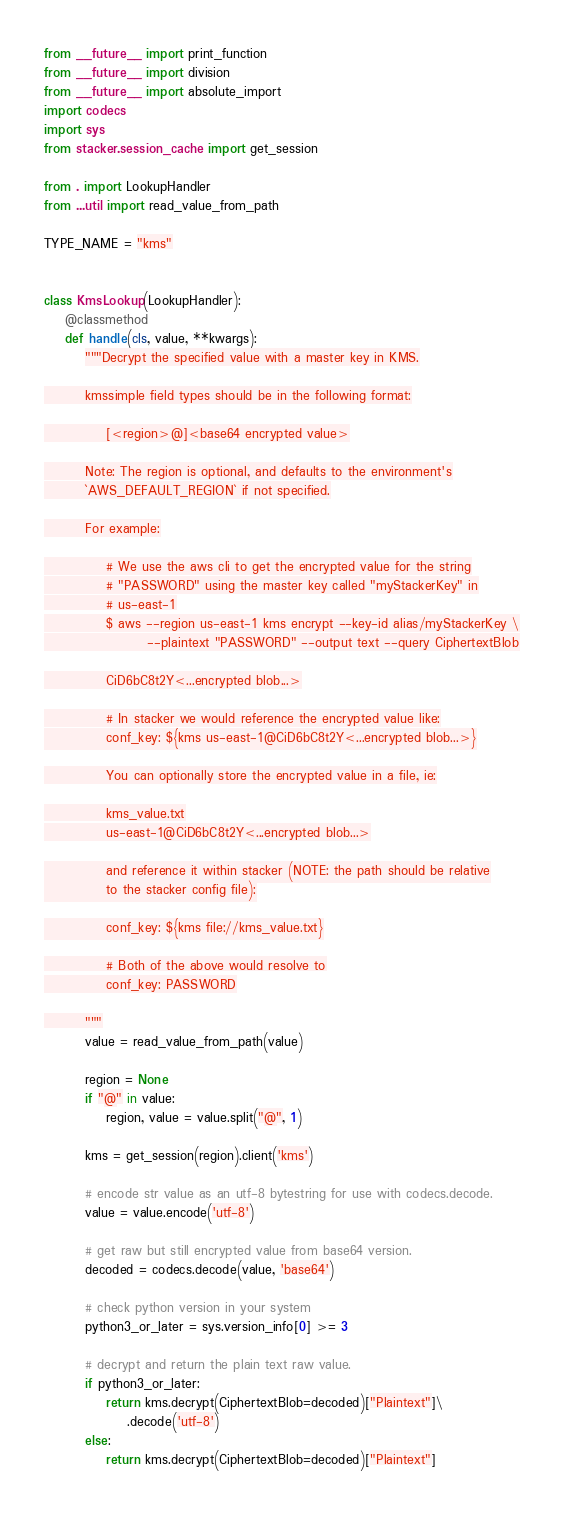<code> <loc_0><loc_0><loc_500><loc_500><_Python_>from __future__ import print_function
from __future__ import division
from __future__ import absolute_import
import codecs
import sys
from stacker.session_cache import get_session

from . import LookupHandler
from ...util import read_value_from_path

TYPE_NAME = "kms"


class KmsLookup(LookupHandler):
    @classmethod
    def handle(cls, value, **kwargs):
        """Decrypt the specified value with a master key in KMS.

        kmssimple field types should be in the following format:

            [<region>@]<base64 encrypted value>

        Note: The region is optional, and defaults to the environment's
        `AWS_DEFAULT_REGION` if not specified.

        For example:

            # We use the aws cli to get the encrypted value for the string
            # "PASSWORD" using the master key called "myStackerKey" in
            # us-east-1
            $ aws --region us-east-1 kms encrypt --key-id alias/myStackerKey \
                    --plaintext "PASSWORD" --output text --query CiphertextBlob

            CiD6bC8t2Y<...encrypted blob...>

            # In stacker we would reference the encrypted value like:
            conf_key: ${kms us-east-1@CiD6bC8t2Y<...encrypted blob...>}

            You can optionally store the encrypted value in a file, ie:

            kms_value.txt
            us-east-1@CiD6bC8t2Y<...encrypted blob...>

            and reference it within stacker (NOTE: the path should be relative
            to the stacker config file):

            conf_key: ${kms file://kms_value.txt}

            # Both of the above would resolve to
            conf_key: PASSWORD

        """
        value = read_value_from_path(value)

        region = None
        if "@" in value:
            region, value = value.split("@", 1)

        kms = get_session(region).client('kms')

        # encode str value as an utf-8 bytestring for use with codecs.decode.
        value = value.encode('utf-8')

        # get raw but still encrypted value from base64 version.
        decoded = codecs.decode(value, 'base64')

        # check python version in your system
        python3_or_later = sys.version_info[0] >= 3

        # decrypt and return the plain text raw value.
        if python3_or_later:
            return kms.decrypt(CiphertextBlob=decoded)["Plaintext"]\
                .decode('utf-8')
        else:
            return kms.decrypt(CiphertextBlob=decoded)["Plaintext"]
</code> 